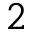Convert formula to latex. <formula><loc_0><loc_0><loc_500><loc_500>2</formula> 